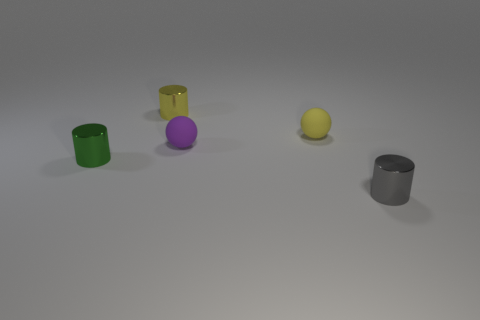Can you describe the textures and materials visible? Certainly! The cylinders and spheres appear to have different surface textures. The green and gold cylinders have a reflective metallic finish, the purple sphere looks like a matte plastic, the yellow sphere has a slightly textured surface that could be rubber or matte paint, and the grey cylinder shows a matte metallic texture. Does this arrangement suggest anything specific to you? This arrangement could be seen as a simplified representation of objects in space or on a tabletop, demonstrating contrast between colors, textures, and forms. It can also be viewed as an abstract composition focusing on the basic geometric shapes and their relationships within a given space. 